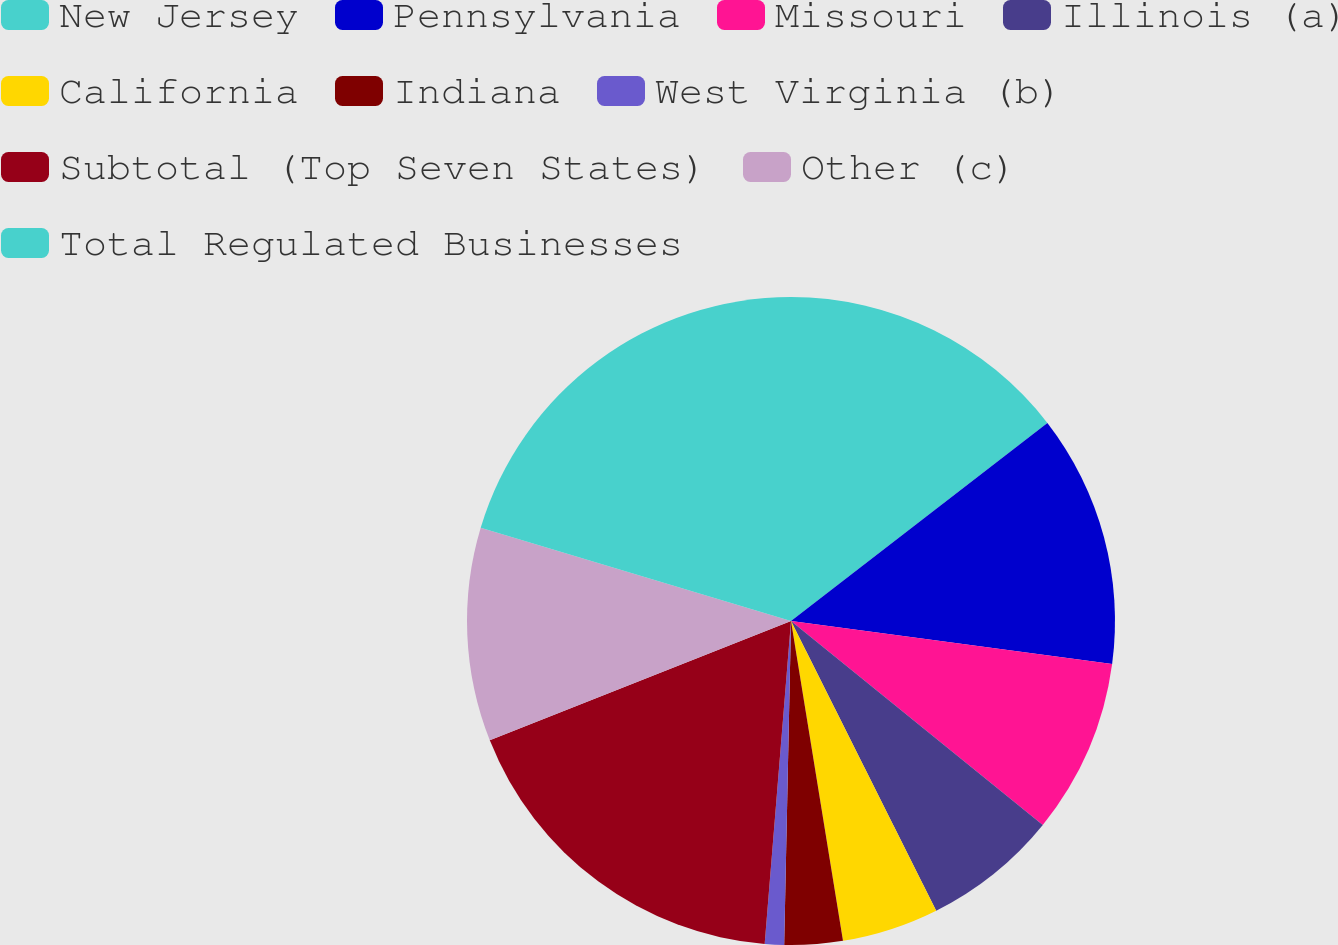Convert chart. <chart><loc_0><loc_0><loc_500><loc_500><pie_chart><fcel>New Jersey<fcel>Pennsylvania<fcel>Missouri<fcel>Illinois (a)<fcel>California<fcel>Indiana<fcel>West Virginia (b)<fcel>Subtotal (Top Seven States)<fcel>Other (c)<fcel>Total Regulated Businesses<nl><fcel>14.53%<fcel>12.59%<fcel>8.71%<fcel>6.77%<fcel>4.83%<fcel>2.9%<fcel>0.96%<fcel>17.7%<fcel>10.65%<fcel>20.35%<nl></chart> 